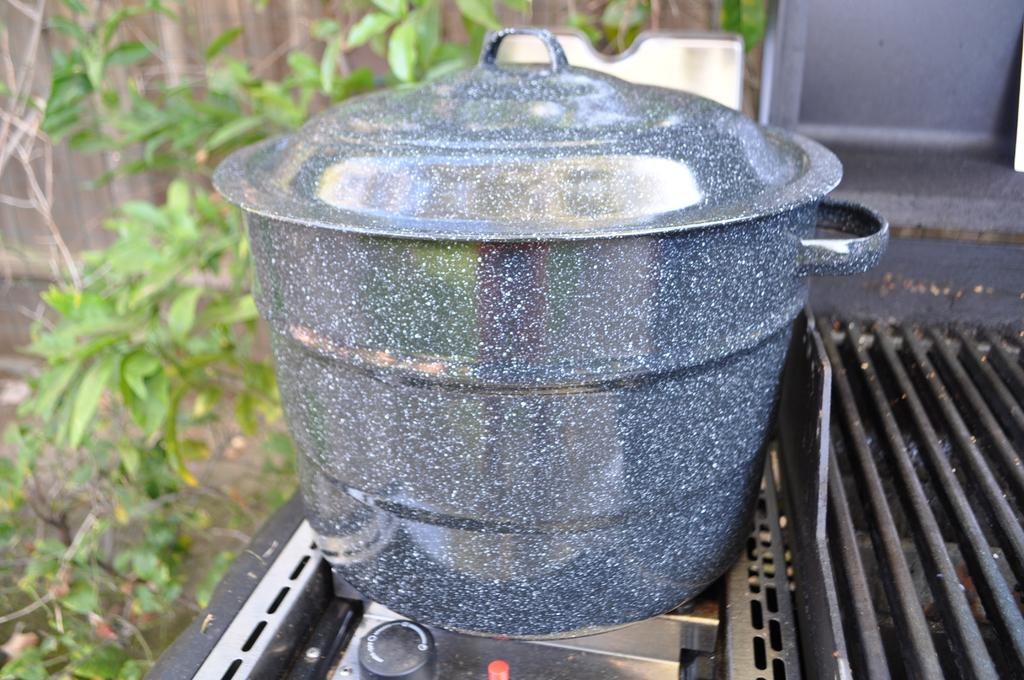What is on the stove in the image? There is a vessel on the stove in the image. What can be seen on the right side of the image? There is a grill on the right side of the image. What type of vegetation is on the left side of the image? There are trees on the left side of the image. How many beads are hanging from the trees on the left side of the image? There are no beads hanging from the trees in the image; only trees are present. What type of mark can be seen on the grill on the right side of the image? There is no mark visible on the grill in the image; only the grill itself is present. 